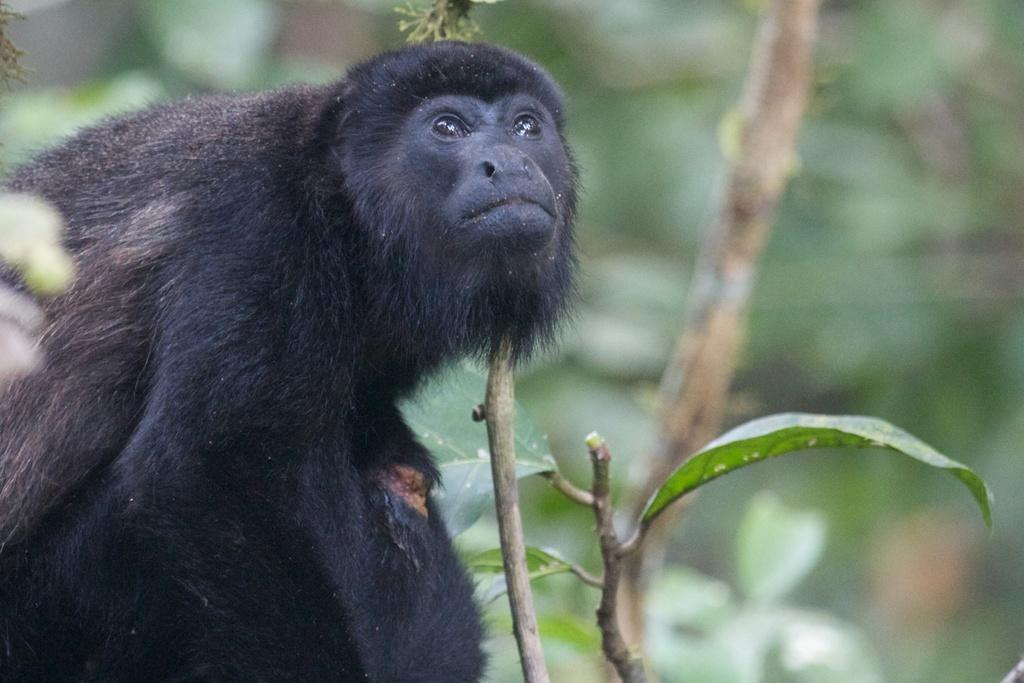What type of creature is present in the image? There is an animal in the image. What color is the animal? The animal is black in color. What other elements can be seen in the image besides the animal? There are leaves visible in the image. How would you describe the background of the image? The background of the image is blurred. What type of basket is hanging from the curtain in the image? There is no basket or curtain present in the image; it only features an animal and leaves. 